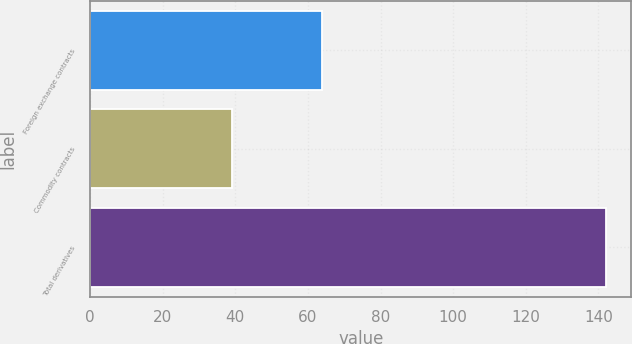<chart> <loc_0><loc_0><loc_500><loc_500><bar_chart><fcel>Foreign exchange contracts<fcel>Commodity contracts<fcel>Total derivatives<nl><fcel>64<fcel>39<fcel>142<nl></chart> 